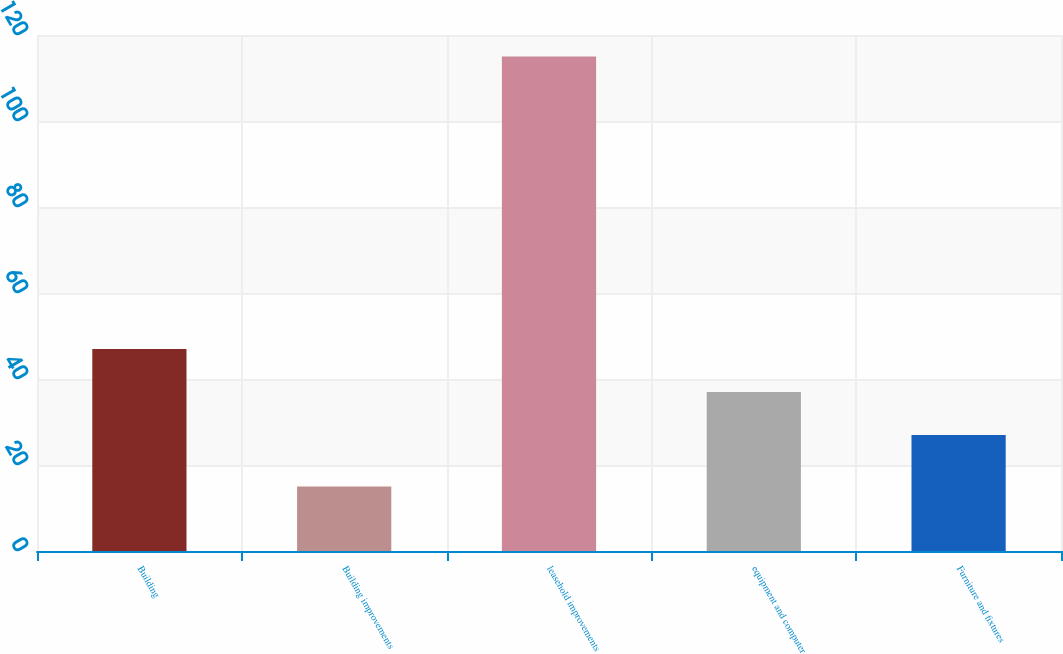<chart> <loc_0><loc_0><loc_500><loc_500><bar_chart><fcel>Building<fcel>Building improvements<fcel>leasehold improvements<fcel>equipment and computer<fcel>Furniture and fixtures<nl><fcel>47<fcel>15<fcel>115<fcel>37<fcel>27<nl></chart> 